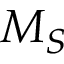<formula> <loc_0><loc_0><loc_500><loc_500>M _ { S }</formula> 